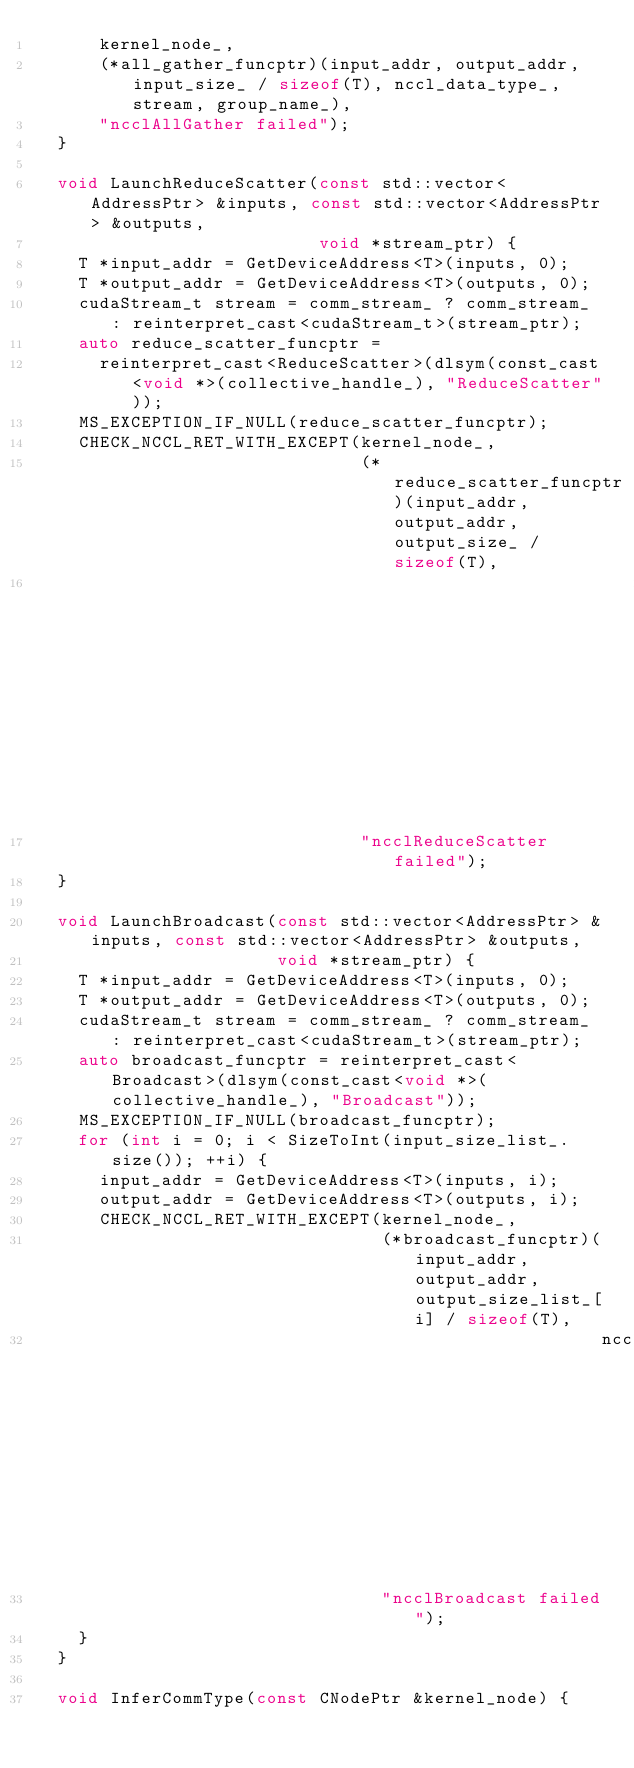<code> <loc_0><loc_0><loc_500><loc_500><_C_>      kernel_node_,
      (*all_gather_funcptr)(input_addr, output_addr, input_size_ / sizeof(T), nccl_data_type_, stream, group_name_),
      "ncclAllGather failed");
  }

  void LaunchReduceScatter(const std::vector<AddressPtr> &inputs, const std::vector<AddressPtr> &outputs,
                           void *stream_ptr) {
    T *input_addr = GetDeviceAddress<T>(inputs, 0);
    T *output_addr = GetDeviceAddress<T>(outputs, 0);
    cudaStream_t stream = comm_stream_ ? comm_stream_ : reinterpret_cast<cudaStream_t>(stream_ptr);
    auto reduce_scatter_funcptr =
      reinterpret_cast<ReduceScatter>(dlsym(const_cast<void *>(collective_handle_), "ReduceScatter"));
    MS_EXCEPTION_IF_NULL(reduce_scatter_funcptr);
    CHECK_NCCL_RET_WITH_EXCEPT(kernel_node_,
                               (*reduce_scatter_funcptr)(input_addr, output_addr, output_size_ / sizeof(T),
                                                         nccl_data_type_, nccl_reduce_type_, stream, group_name_),
                               "ncclReduceScatter failed");
  }

  void LaunchBroadcast(const std::vector<AddressPtr> &inputs, const std::vector<AddressPtr> &outputs,
                       void *stream_ptr) {
    T *input_addr = GetDeviceAddress<T>(inputs, 0);
    T *output_addr = GetDeviceAddress<T>(outputs, 0);
    cudaStream_t stream = comm_stream_ ? comm_stream_ : reinterpret_cast<cudaStream_t>(stream_ptr);
    auto broadcast_funcptr = reinterpret_cast<Broadcast>(dlsym(const_cast<void *>(collective_handle_), "Broadcast"));
    MS_EXCEPTION_IF_NULL(broadcast_funcptr);
    for (int i = 0; i < SizeToInt(input_size_list_.size()); ++i) {
      input_addr = GetDeviceAddress<T>(inputs, i);
      output_addr = GetDeviceAddress<T>(outputs, i);
      CHECK_NCCL_RET_WITH_EXCEPT(kernel_node_,
                                 (*broadcast_funcptr)(input_addr, output_addr, output_size_list_[i] / sizeof(T),
                                                      nccl_data_type_, root_, stream, group_name_),
                                 "ncclBroadcast failed");
    }
  }

  void InferCommType(const CNodePtr &kernel_node) {</code> 